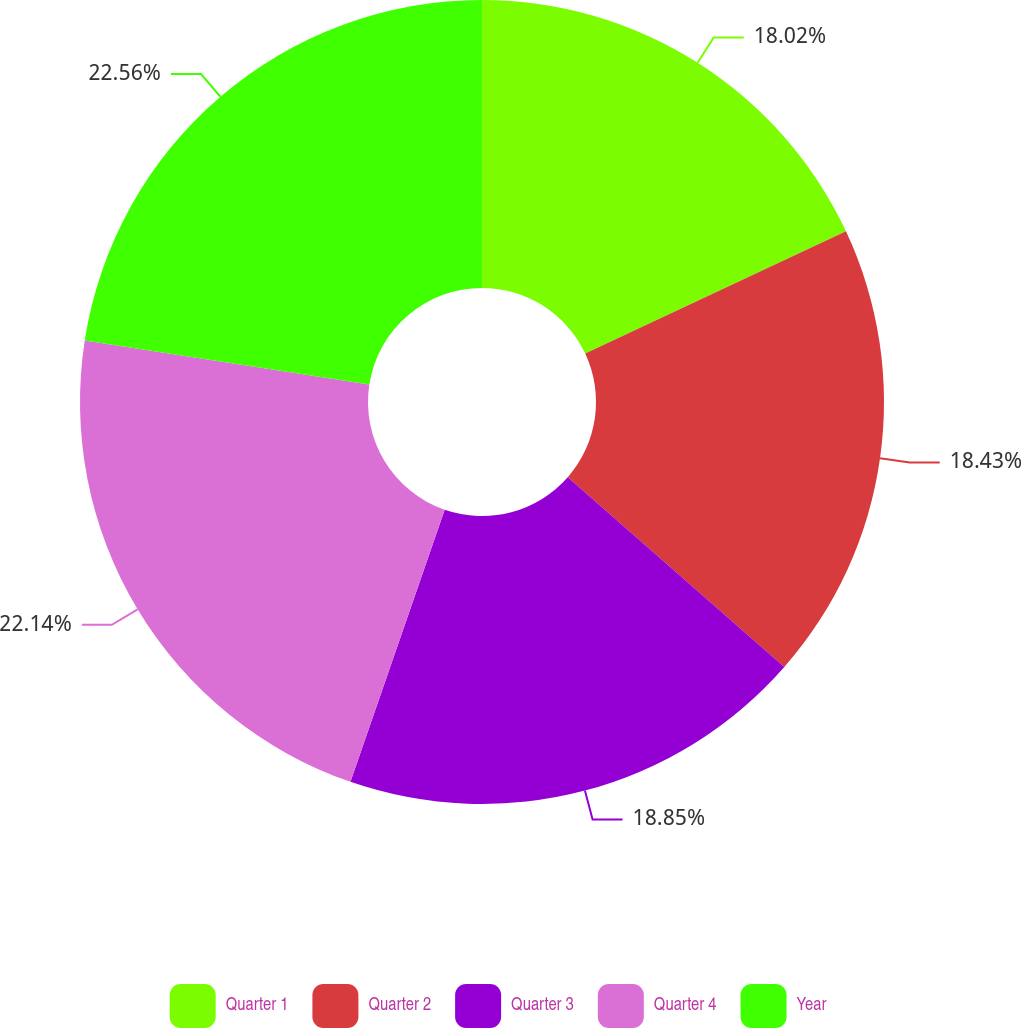Convert chart. <chart><loc_0><loc_0><loc_500><loc_500><pie_chart><fcel>Quarter 1<fcel>Quarter 2<fcel>Quarter 3<fcel>Quarter 4<fcel>Year<nl><fcel>18.02%<fcel>18.43%<fcel>18.85%<fcel>22.14%<fcel>22.55%<nl></chart> 